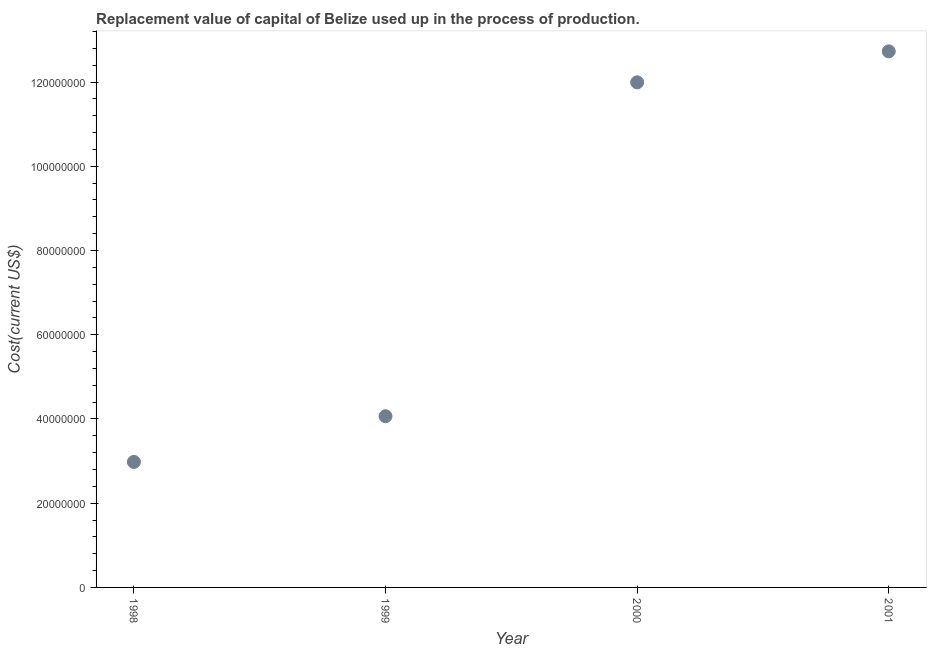What is the consumption of fixed capital in 1998?
Your answer should be very brief. 2.98e+07. Across all years, what is the maximum consumption of fixed capital?
Offer a very short reply. 1.27e+08. Across all years, what is the minimum consumption of fixed capital?
Keep it short and to the point. 2.98e+07. In which year was the consumption of fixed capital maximum?
Your answer should be compact. 2001. What is the sum of the consumption of fixed capital?
Keep it short and to the point. 3.18e+08. What is the difference between the consumption of fixed capital in 2000 and 2001?
Your answer should be very brief. -7.36e+06. What is the average consumption of fixed capital per year?
Your answer should be compact. 7.94e+07. What is the median consumption of fixed capital?
Give a very brief answer. 8.03e+07. Do a majority of the years between 2000 and 2001 (inclusive) have consumption of fixed capital greater than 52000000 US$?
Give a very brief answer. Yes. What is the ratio of the consumption of fixed capital in 2000 to that in 2001?
Keep it short and to the point. 0.94. What is the difference between the highest and the second highest consumption of fixed capital?
Give a very brief answer. 7.36e+06. Is the sum of the consumption of fixed capital in 1998 and 2001 greater than the maximum consumption of fixed capital across all years?
Give a very brief answer. Yes. What is the difference between the highest and the lowest consumption of fixed capital?
Offer a very short reply. 9.75e+07. In how many years, is the consumption of fixed capital greater than the average consumption of fixed capital taken over all years?
Keep it short and to the point. 2. How many years are there in the graph?
Provide a succinct answer. 4. What is the difference between two consecutive major ticks on the Y-axis?
Provide a succinct answer. 2.00e+07. Are the values on the major ticks of Y-axis written in scientific E-notation?
Offer a very short reply. No. Does the graph contain any zero values?
Keep it short and to the point. No. What is the title of the graph?
Offer a terse response. Replacement value of capital of Belize used up in the process of production. What is the label or title of the X-axis?
Offer a terse response. Year. What is the label or title of the Y-axis?
Your response must be concise. Cost(current US$). What is the Cost(current US$) in 1998?
Provide a succinct answer. 2.98e+07. What is the Cost(current US$) in 1999?
Give a very brief answer. 4.07e+07. What is the Cost(current US$) in 2000?
Keep it short and to the point. 1.20e+08. What is the Cost(current US$) in 2001?
Provide a succinct answer. 1.27e+08. What is the difference between the Cost(current US$) in 1998 and 1999?
Your answer should be very brief. -1.09e+07. What is the difference between the Cost(current US$) in 1998 and 2000?
Offer a terse response. -9.01e+07. What is the difference between the Cost(current US$) in 1998 and 2001?
Make the answer very short. -9.75e+07. What is the difference between the Cost(current US$) in 1999 and 2000?
Your answer should be very brief. -7.93e+07. What is the difference between the Cost(current US$) in 1999 and 2001?
Ensure brevity in your answer.  -8.66e+07. What is the difference between the Cost(current US$) in 2000 and 2001?
Make the answer very short. -7.36e+06. What is the ratio of the Cost(current US$) in 1998 to that in 1999?
Give a very brief answer. 0.73. What is the ratio of the Cost(current US$) in 1998 to that in 2000?
Your response must be concise. 0.25. What is the ratio of the Cost(current US$) in 1998 to that in 2001?
Keep it short and to the point. 0.23. What is the ratio of the Cost(current US$) in 1999 to that in 2000?
Your answer should be very brief. 0.34. What is the ratio of the Cost(current US$) in 1999 to that in 2001?
Provide a succinct answer. 0.32. What is the ratio of the Cost(current US$) in 2000 to that in 2001?
Give a very brief answer. 0.94. 